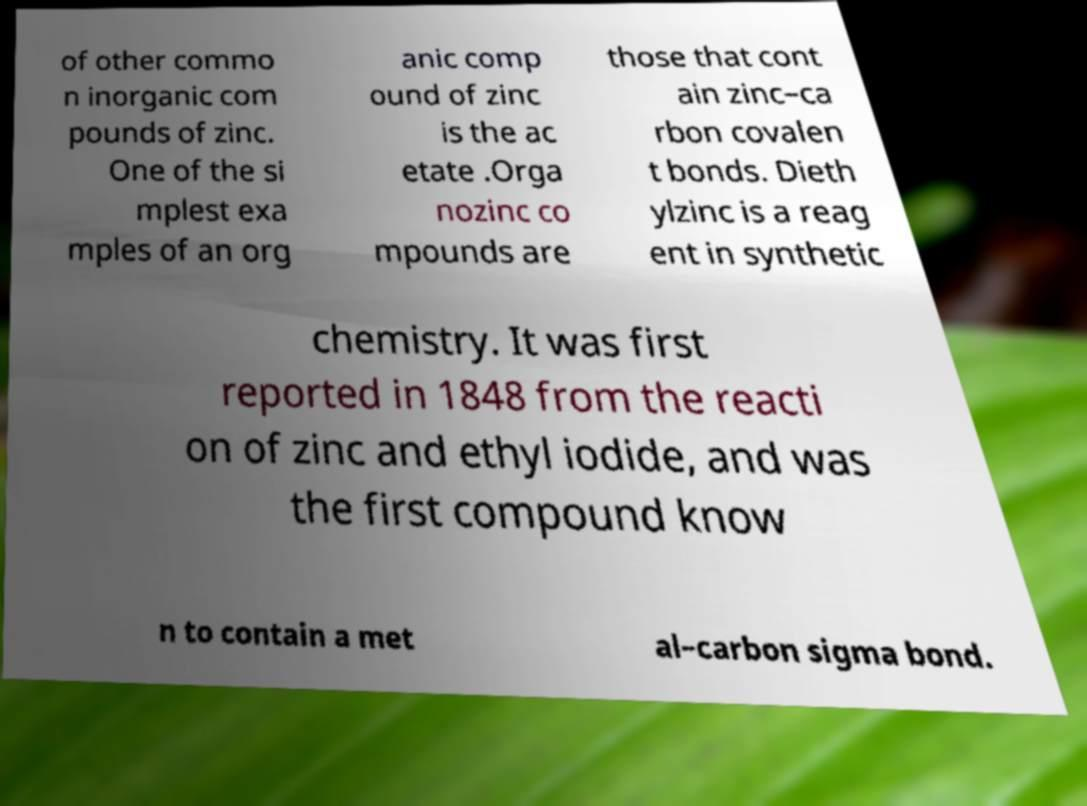Can you accurately transcribe the text from the provided image for me? of other commo n inorganic com pounds of zinc. One of the si mplest exa mples of an org anic comp ound of zinc is the ac etate .Orga nozinc co mpounds are those that cont ain zinc–ca rbon covalen t bonds. Dieth ylzinc is a reag ent in synthetic chemistry. It was first reported in 1848 from the reacti on of zinc and ethyl iodide, and was the first compound know n to contain a met al–carbon sigma bond. 